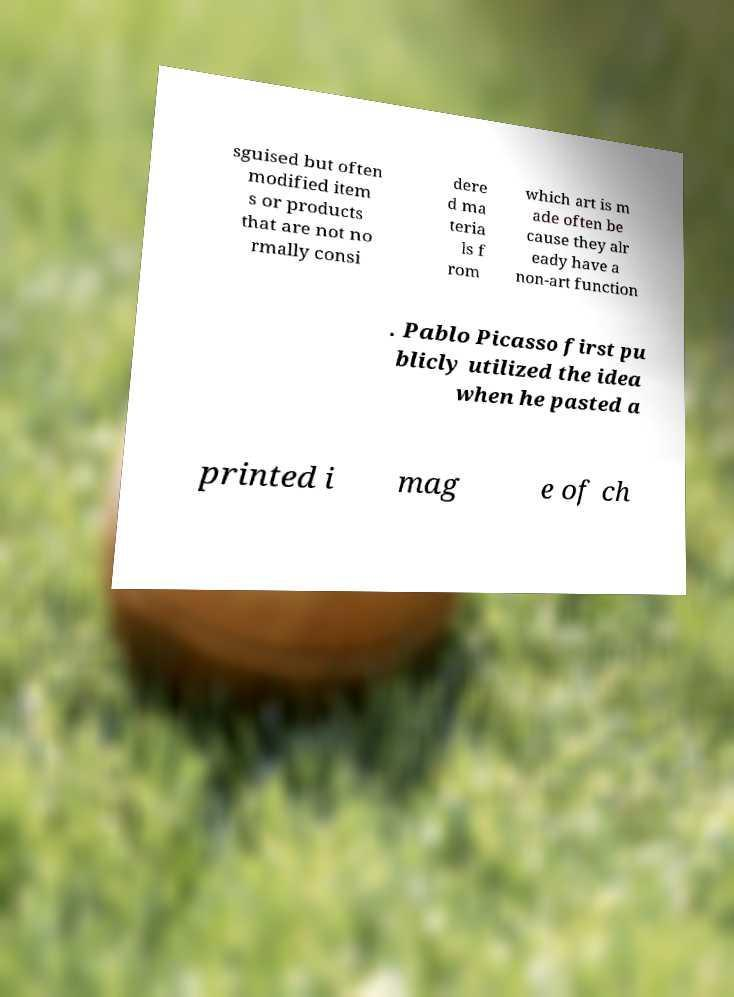Can you accurately transcribe the text from the provided image for me? sguised but often modified item s or products that are not no rmally consi dere d ma teria ls f rom which art is m ade often be cause they alr eady have a non-art function . Pablo Picasso first pu blicly utilized the idea when he pasted a printed i mag e of ch 